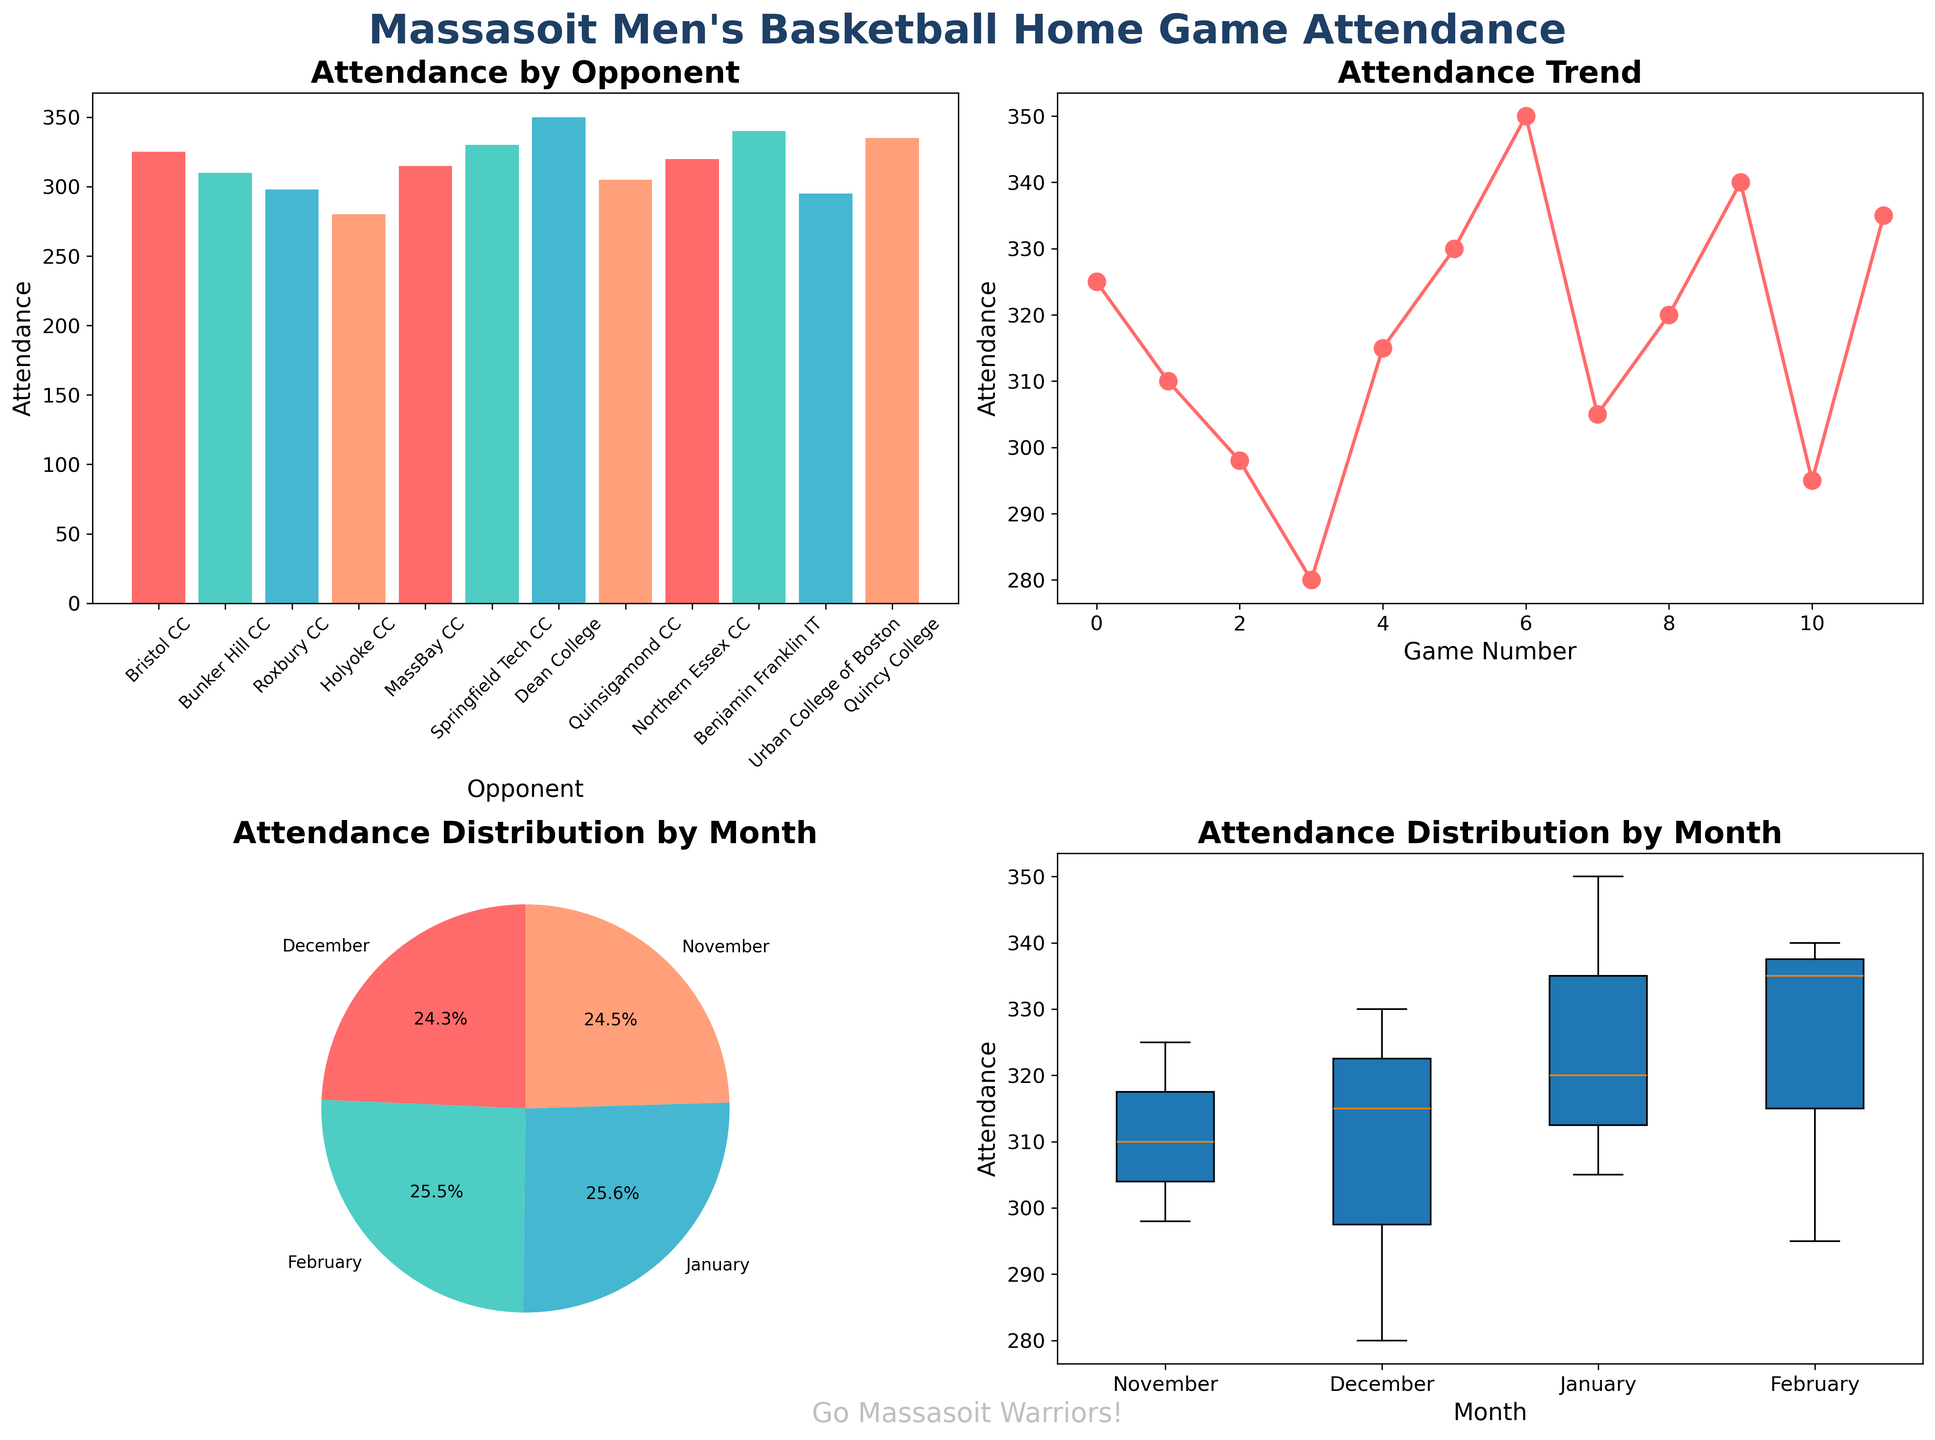Which opponent had the highest attendance? By looking at the bar chart (top-left plot), we notice that Dean College had the tallest bar, indicating the highest attendance.
Answer: Dean College What is the attendance trend shown in the line plot? In the line plot (top-right plot), we see the attendance is generally increasing with some fluctuations, starting around 300 and peaking at 350 before slightly dropping.
Answer: Increasing with fluctuations Which month had the highest total attendance? The pie chart (bottom-left plot) shows the attendance distribution by month. The slice representing January is the largest, indicating the highest total attendance.
Answer: January What's the range of attendance values for December? In the box plot (bottom-right plot), the December box shows the minimum and maximum attendance values. The range is from 280 to 330.
Answer: 280 to 330 Which month had the lowest variation in attendance? The box plot (bottom-right plot) shows variation in attendance for each month. February has the smallest box, indicating the lowest variation.
Answer: February What's the average attendance for January games? We can compute the average by taking the three attendance values from January games (350, 305, and 320) and averaging them. (350 + 305 + 320) / 3 = 325.
Answer: 325 How does the attendance of Bristol CC compare with Bunker Hill CC? By comparing the bars in the bar chart (top-left plot) for Bristol CC and Bunker Hill CC, we notice Bristol CC had a higher attendance (325 vs. 310).
Answer: Bristol CC had higher attendance What's the spread of attendance values for November games? In the box plot (bottom-right plot), the November spread ranges from the minimum attendance of 298 to the maximum of 325.
Answer: 298 to 325 Which game had the lowest attendance? By examining the bar chart (top-left plot) or the line plot (top-right plot), we see that the game against Roxbury CC had the lowest attendance.
Answer: Roxbury CC What percentage of total season attendance occurred in February? From the pie chart (bottom-left plot), we see February's slice representing 23.1% of the total season attendance.
Answer: 23.1% 